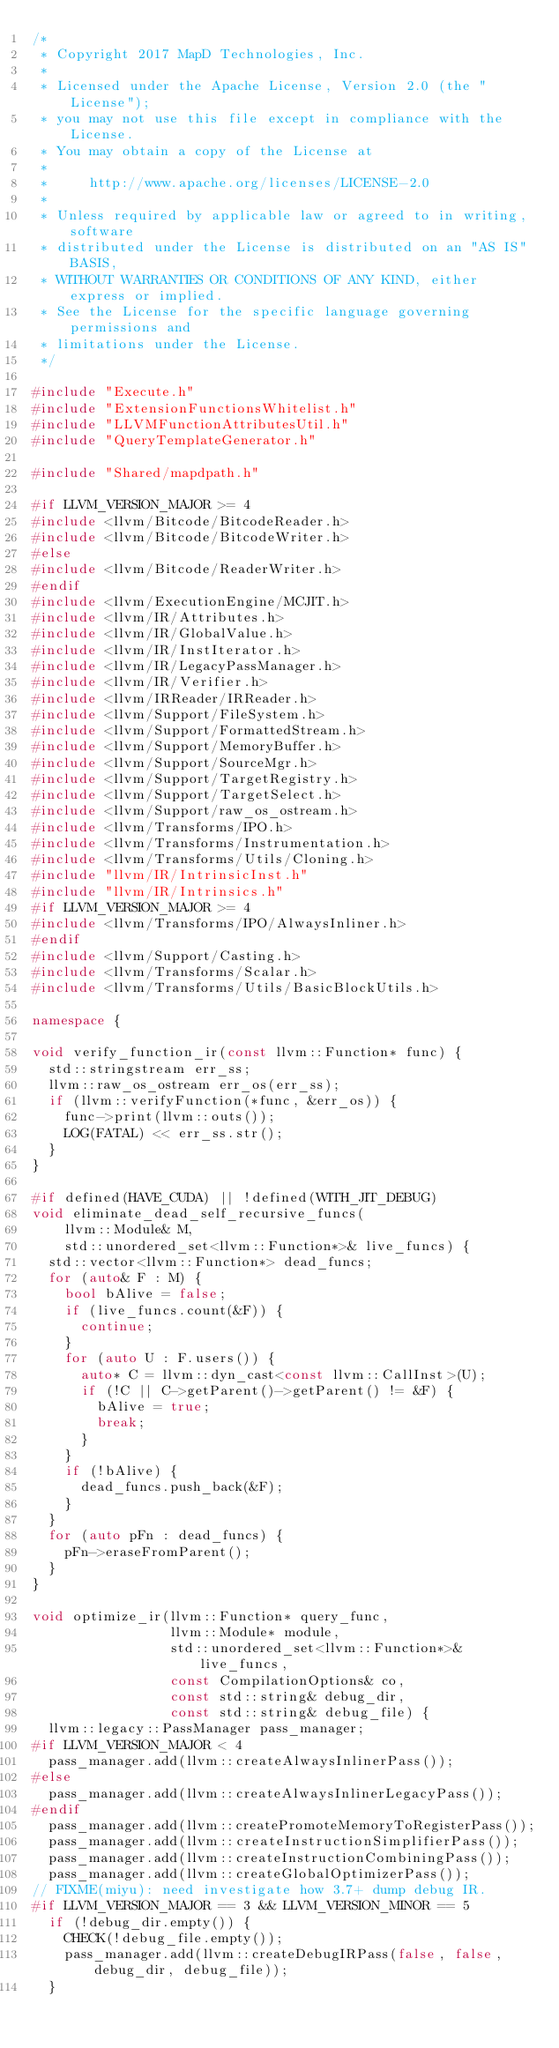<code> <loc_0><loc_0><loc_500><loc_500><_C++_>/*
 * Copyright 2017 MapD Technologies, Inc.
 *
 * Licensed under the Apache License, Version 2.0 (the "License");
 * you may not use this file except in compliance with the License.
 * You may obtain a copy of the License at
 *
 *     http://www.apache.org/licenses/LICENSE-2.0
 *
 * Unless required by applicable law or agreed to in writing, software
 * distributed under the License is distributed on an "AS IS" BASIS,
 * WITHOUT WARRANTIES OR CONDITIONS OF ANY KIND, either express or implied.
 * See the License for the specific language governing permissions and
 * limitations under the License.
 */

#include "Execute.h"
#include "ExtensionFunctionsWhitelist.h"
#include "LLVMFunctionAttributesUtil.h"
#include "QueryTemplateGenerator.h"

#include "Shared/mapdpath.h"

#if LLVM_VERSION_MAJOR >= 4
#include <llvm/Bitcode/BitcodeReader.h>
#include <llvm/Bitcode/BitcodeWriter.h>
#else
#include <llvm/Bitcode/ReaderWriter.h>
#endif
#include <llvm/ExecutionEngine/MCJIT.h>
#include <llvm/IR/Attributes.h>
#include <llvm/IR/GlobalValue.h>
#include <llvm/IR/InstIterator.h>
#include <llvm/IR/LegacyPassManager.h>
#include <llvm/IR/Verifier.h>
#include <llvm/IRReader/IRReader.h>
#include <llvm/Support/FileSystem.h>
#include <llvm/Support/FormattedStream.h>
#include <llvm/Support/MemoryBuffer.h>
#include <llvm/Support/SourceMgr.h>
#include <llvm/Support/TargetRegistry.h>
#include <llvm/Support/TargetSelect.h>
#include <llvm/Support/raw_os_ostream.h>
#include <llvm/Transforms/IPO.h>
#include <llvm/Transforms/Instrumentation.h>
#include <llvm/Transforms/Utils/Cloning.h>
#include "llvm/IR/IntrinsicInst.h"
#include "llvm/IR/Intrinsics.h"
#if LLVM_VERSION_MAJOR >= 4
#include <llvm/Transforms/IPO/AlwaysInliner.h>
#endif
#include <llvm/Support/Casting.h>
#include <llvm/Transforms/Scalar.h>
#include <llvm/Transforms/Utils/BasicBlockUtils.h>

namespace {

void verify_function_ir(const llvm::Function* func) {
  std::stringstream err_ss;
  llvm::raw_os_ostream err_os(err_ss);
  if (llvm::verifyFunction(*func, &err_os)) {
    func->print(llvm::outs());
    LOG(FATAL) << err_ss.str();
  }
}

#if defined(HAVE_CUDA) || !defined(WITH_JIT_DEBUG)
void eliminate_dead_self_recursive_funcs(
    llvm::Module& M,
    std::unordered_set<llvm::Function*>& live_funcs) {
  std::vector<llvm::Function*> dead_funcs;
  for (auto& F : M) {
    bool bAlive = false;
    if (live_funcs.count(&F)) {
      continue;
    }
    for (auto U : F.users()) {
      auto* C = llvm::dyn_cast<const llvm::CallInst>(U);
      if (!C || C->getParent()->getParent() != &F) {
        bAlive = true;
        break;
      }
    }
    if (!bAlive) {
      dead_funcs.push_back(&F);
    }
  }
  for (auto pFn : dead_funcs) {
    pFn->eraseFromParent();
  }
}

void optimize_ir(llvm::Function* query_func,
                 llvm::Module* module,
                 std::unordered_set<llvm::Function*>& live_funcs,
                 const CompilationOptions& co,
                 const std::string& debug_dir,
                 const std::string& debug_file) {
  llvm::legacy::PassManager pass_manager;
#if LLVM_VERSION_MAJOR < 4
  pass_manager.add(llvm::createAlwaysInlinerPass());
#else
  pass_manager.add(llvm::createAlwaysInlinerLegacyPass());
#endif
  pass_manager.add(llvm::createPromoteMemoryToRegisterPass());
  pass_manager.add(llvm::createInstructionSimplifierPass());
  pass_manager.add(llvm::createInstructionCombiningPass());
  pass_manager.add(llvm::createGlobalOptimizerPass());
// FIXME(miyu): need investigate how 3.7+ dump debug IR.
#if LLVM_VERSION_MAJOR == 3 && LLVM_VERSION_MINOR == 5
  if (!debug_dir.empty()) {
    CHECK(!debug_file.empty());
    pass_manager.add(llvm::createDebugIRPass(false, false, debug_dir, debug_file));
  }</code> 